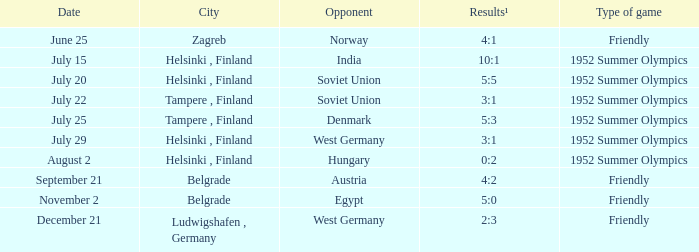What is the name of the City with December 21 as a Date? Ludwigshafen , Germany. 